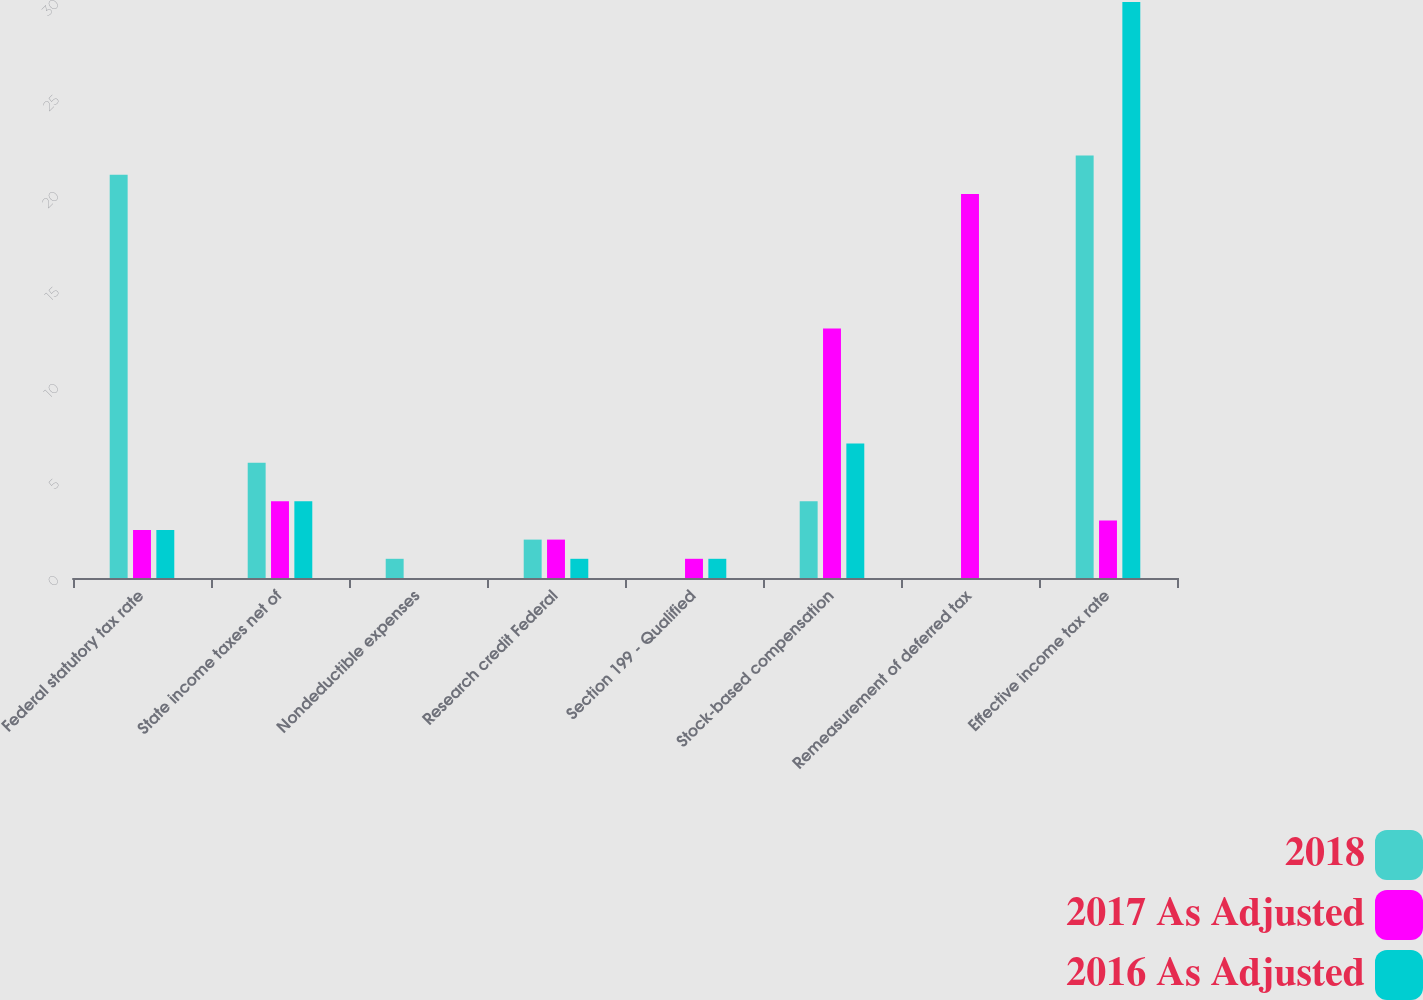Convert chart. <chart><loc_0><loc_0><loc_500><loc_500><stacked_bar_chart><ecel><fcel>Federal statutory tax rate<fcel>State income taxes net of<fcel>Nondeductible expenses<fcel>Research credit Federal<fcel>Section 199 - Qualified<fcel>Stock-based compensation<fcel>Remeasurement of deferred tax<fcel>Effective income tax rate<nl><fcel>2018<fcel>21<fcel>6<fcel>1<fcel>2<fcel>0<fcel>4<fcel>0<fcel>22<nl><fcel>2017 As Adjusted<fcel>2.5<fcel>4<fcel>0<fcel>2<fcel>1<fcel>13<fcel>20<fcel>3<nl><fcel>2016 As Adjusted<fcel>2.5<fcel>4<fcel>0<fcel>1<fcel>1<fcel>7<fcel>0<fcel>30<nl></chart> 